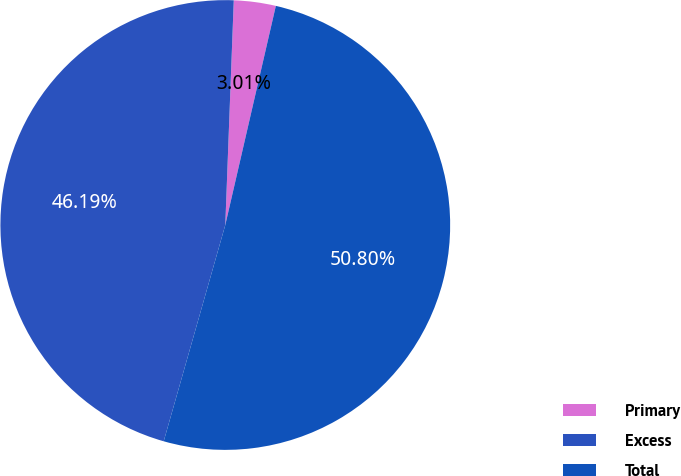<chart> <loc_0><loc_0><loc_500><loc_500><pie_chart><fcel>Primary<fcel>Excess<fcel>Total<nl><fcel>3.01%<fcel>46.19%<fcel>50.81%<nl></chart> 